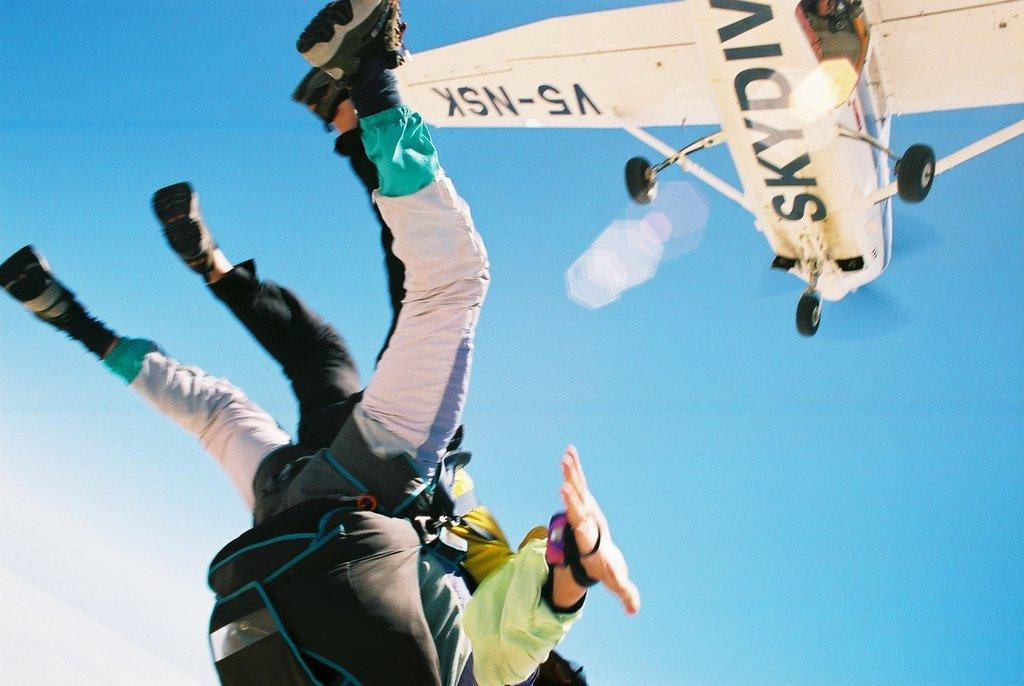How many people are in the image? There are two men in the image. What are the men wearing? The men are wearing white costumes. What additional items can be seen on the men? The men have backpacks on their backs. What activity are the men engaged in? The men are skydiving. What can be seen in the sky besides the men? There is a small aircraft in the sky. What is the color of the aircraft? The aircraft is white in color. What type of protest is taking place in the image? There is no protest present in the image; it features two men skydiving with a white aircraft in the sky. Can you tell me what kind of wine is being served in the image? There is no wine present in the image. 